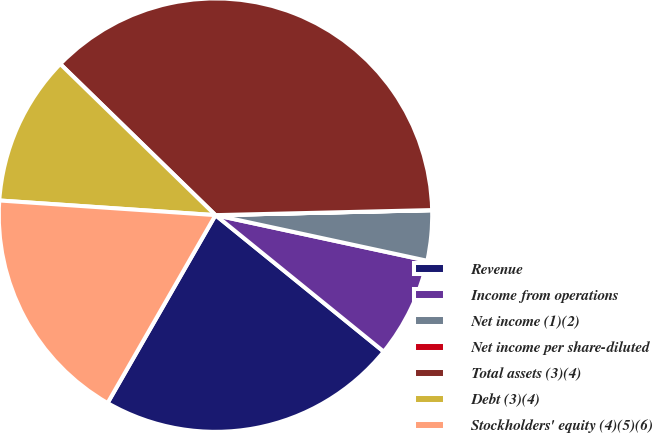<chart> <loc_0><loc_0><loc_500><loc_500><pie_chart><fcel>Revenue<fcel>Income from operations<fcel>Net income (1)(2)<fcel>Net income per share-diluted<fcel>Total assets (3)(4)<fcel>Debt (3)(4)<fcel>Stockholders' equity (4)(5)(6)<nl><fcel>22.45%<fcel>7.47%<fcel>3.74%<fcel>0.01%<fcel>37.34%<fcel>11.21%<fcel>17.78%<nl></chart> 